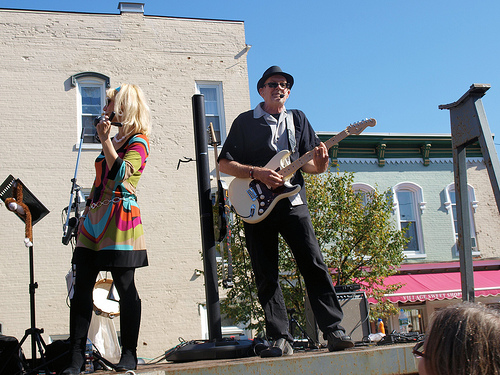<image>
Can you confirm if the male singer is to the left of the female singer? No. The male singer is not to the left of the female singer. From this viewpoint, they have a different horizontal relationship. Is the guitar next to the woman? Yes. The guitar is positioned adjacent to the woman, located nearby in the same general area. 